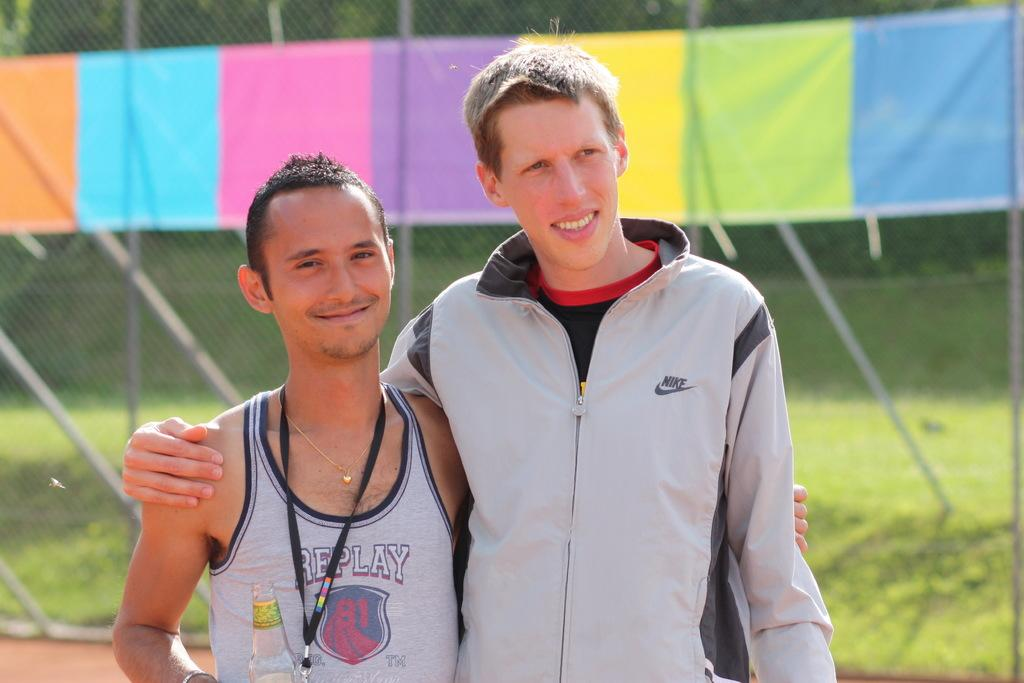<image>
Summarize the visual content of the image. Two people, one of whom is wearing a Nike jacket, pose for a picture. 